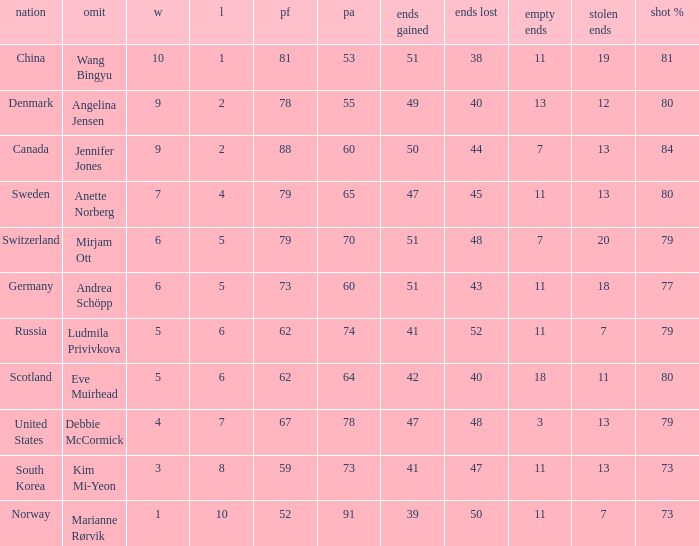Andrea Schöpp is the skip of which country? Germany. 